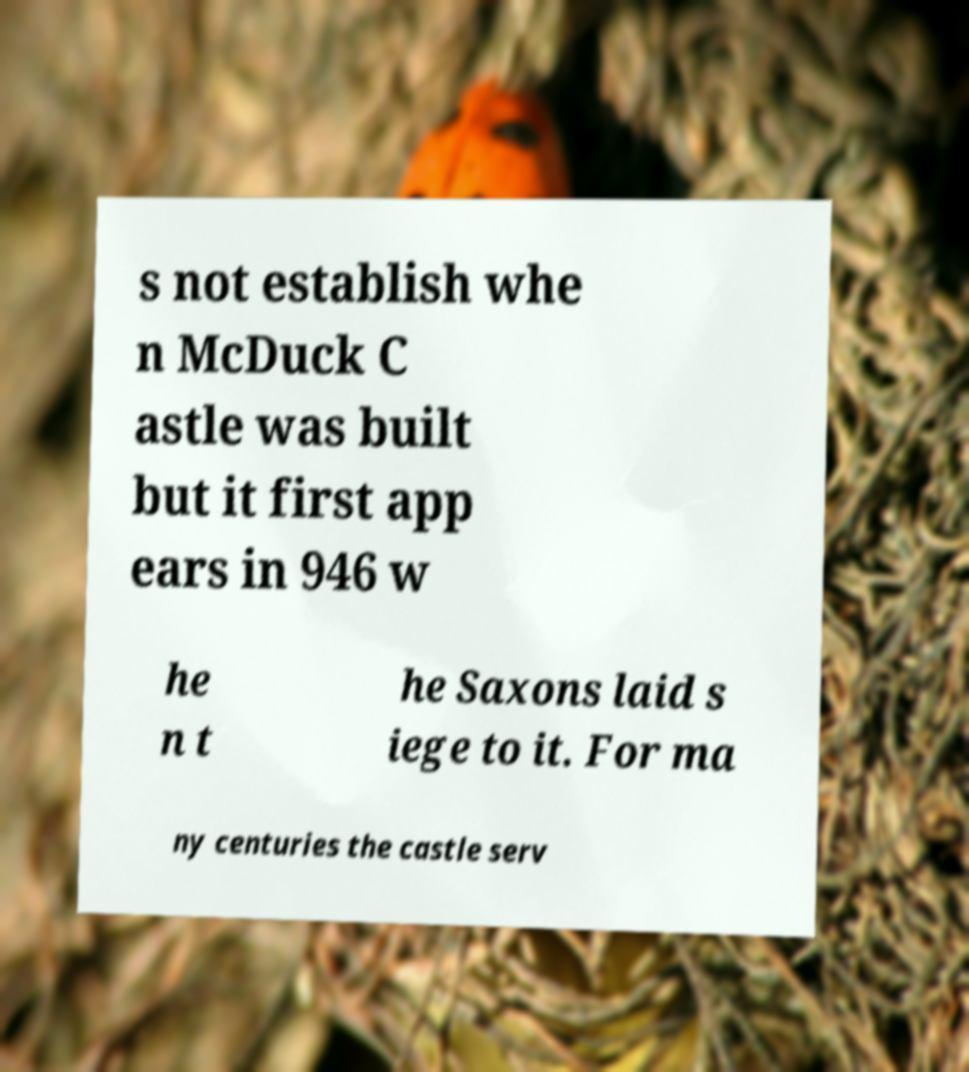For documentation purposes, I need the text within this image transcribed. Could you provide that? s not establish whe n McDuck C astle was built but it first app ears in 946 w he n t he Saxons laid s iege to it. For ma ny centuries the castle serv 